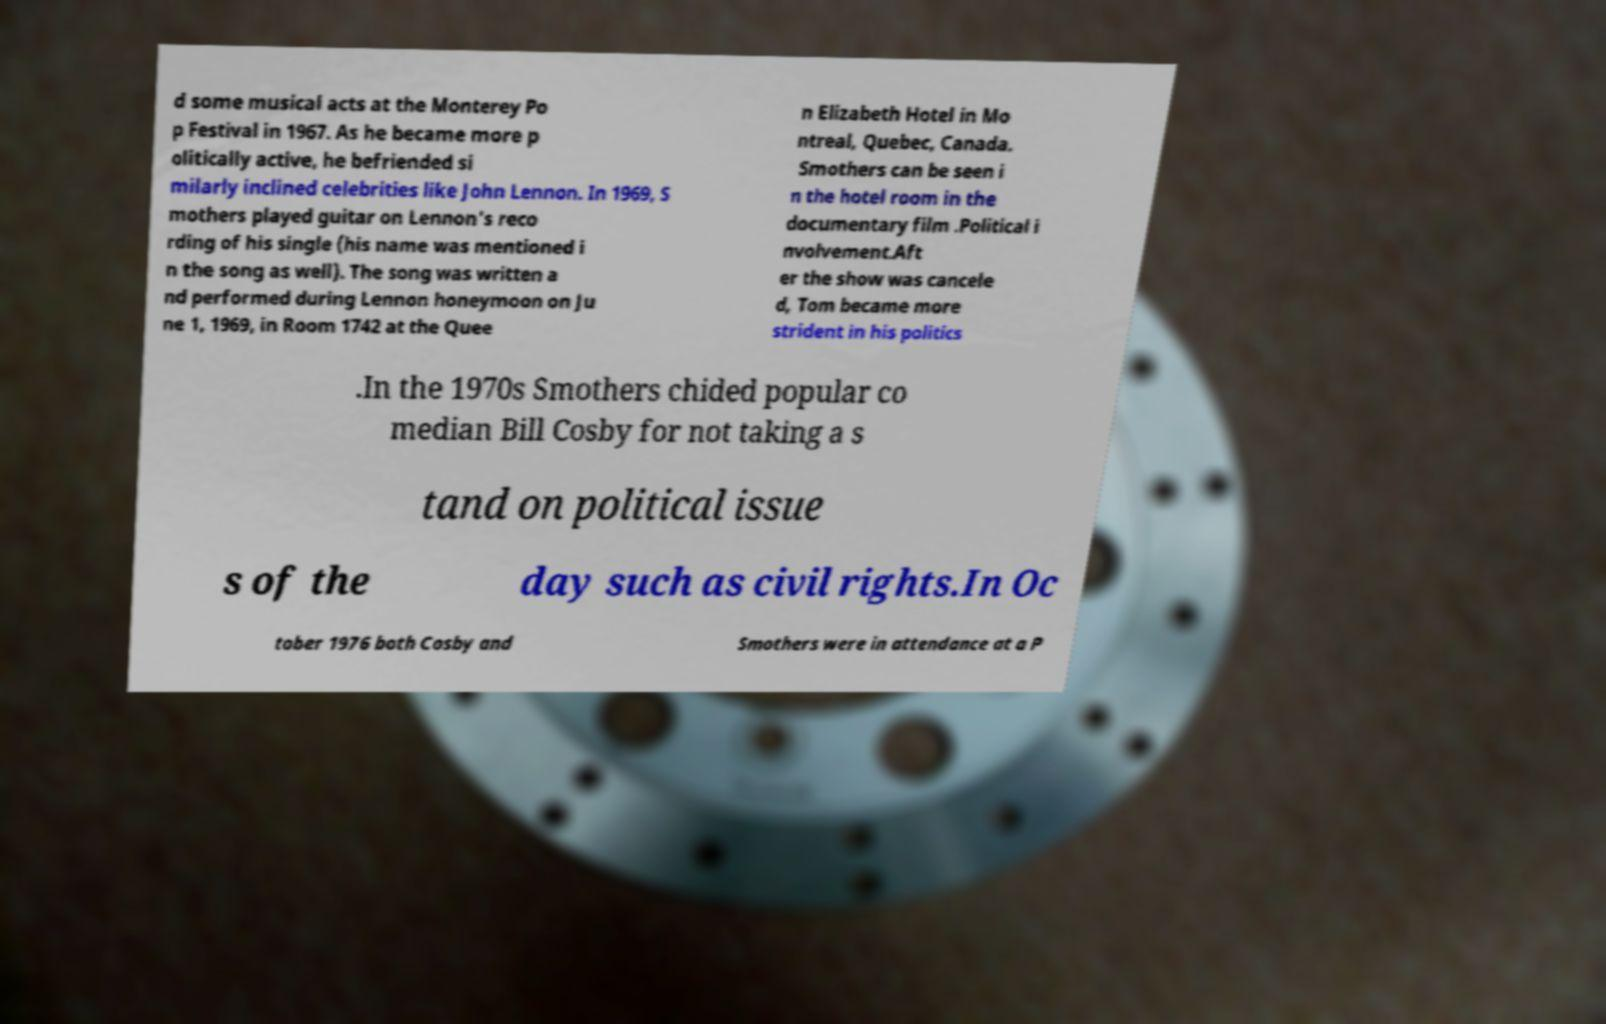Could you extract and type out the text from this image? d some musical acts at the Monterey Po p Festival in 1967. As he became more p olitically active, he befriended si milarly inclined celebrities like John Lennon. In 1969, S mothers played guitar on Lennon's reco rding of his single (his name was mentioned i n the song as well). The song was written a nd performed during Lennon honeymoon on Ju ne 1, 1969, in Room 1742 at the Quee n Elizabeth Hotel in Mo ntreal, Quebec, Canada. Smothers can be seen i n the hotel room in the documentary film .Political i nvolvement.Aft er the show was cancele d, Tom became more strident in his politics .In the 1970s Smothers chided popular co median Bill Cosby for not taking a s tand on political issue s of the day such as civil rights.In Oc tober 1976 both Cosby and Smothers were in attendance at a P 